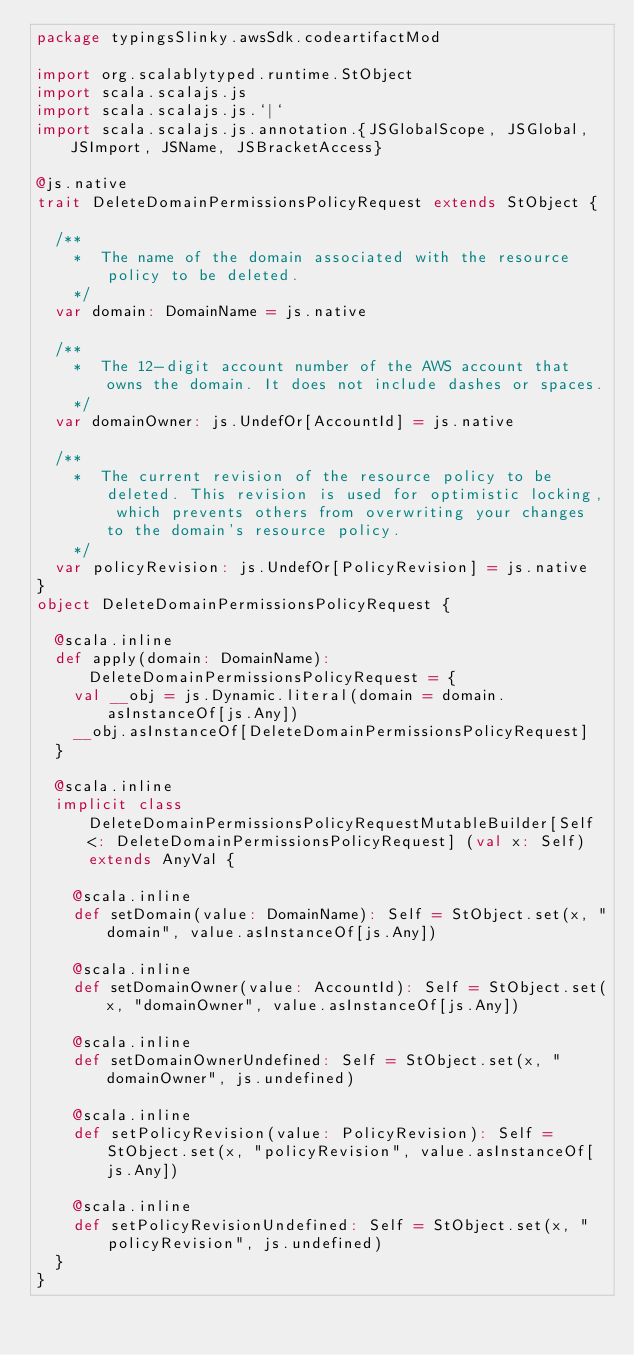Convert code to text. <code><loc_0><loc_0><loc_500><loc_500><_Scala_>package typingsSlinky.awsSdk.codeartifactMod

import org.scalablytyped.runtime.StObject
import scala.scalajs.js
import scala.scalajs.js.`|`
import scala.scalajs.js.annotation.{JSGlobalScope, JSGlobal, JSImport, JSName, JSBracketAccess}

@js.native
trait DeleteDomainPermissionsPolicyRequest extends StObject {
  
  /**
    *  The name of the domain associated with the resource policy to be deleted. 
    */
  var domain: DomainName = js.native
  
  /**
    *  The 12-digit account number of the AWS account that owns the domain. It does not include dashes or spaces. 
    */
  var domainOwner: js.UndefOr[AccountId] = js.native
  
  /**
    *  The current revision of the resource policy to be deleted. This revision is used for optimistic locking, which prevents others from overwriting your changes to the domain's resource policy. 
    */
  var policyRevision: js.UndefOr[PolicyRevision] = js.native
}
object DeleteDomainPermissionsPolicyRequest {
  
  @scala.inline
  def apply(domain: DomainName): DeleteDomainPermissionsPolicyRequest = {
    val __obj = js.Dynamic.literal(domain = domain.asInstanceOf[js.Any])
    __obj.asInstanceOf[DeleteDomainPermissionsPolicyRequest]
  }
  
  @scala.inline
  implicit class DeleteDomainPermissionsPolicyRequestMutableBuilder[Self <: DeleteDomainPermissionsPolicyRequest] (val x: Self) extends AnyVal {
    
    @scala.inline
    def setDomain(value: DomainName): Self = StObject.set(x, "domain", value.asInstanceOf[js.Any])
    
    @scala.inline
    def setDomainOwner(value: AccountId): Self = StObject.set(x, "domainOwner", value.asInstanceOf[js.Any])
    
    @scala.inline
    def setDomainOwnerUndefined: Self = StObject.set(x, "domainOwner", js.undefined)
    
    @scala.inline
    def setPolicyRevision(value: PolicyRevision): Self = StObject.set(x, "policyRevision", value.asInstanceOf[js.Any])
    
    @scala.inline
    def setPolicyRevisionUndefined: Self = StObject.set(x, "policyRevision", js.undefined)
  }
}
</code> 